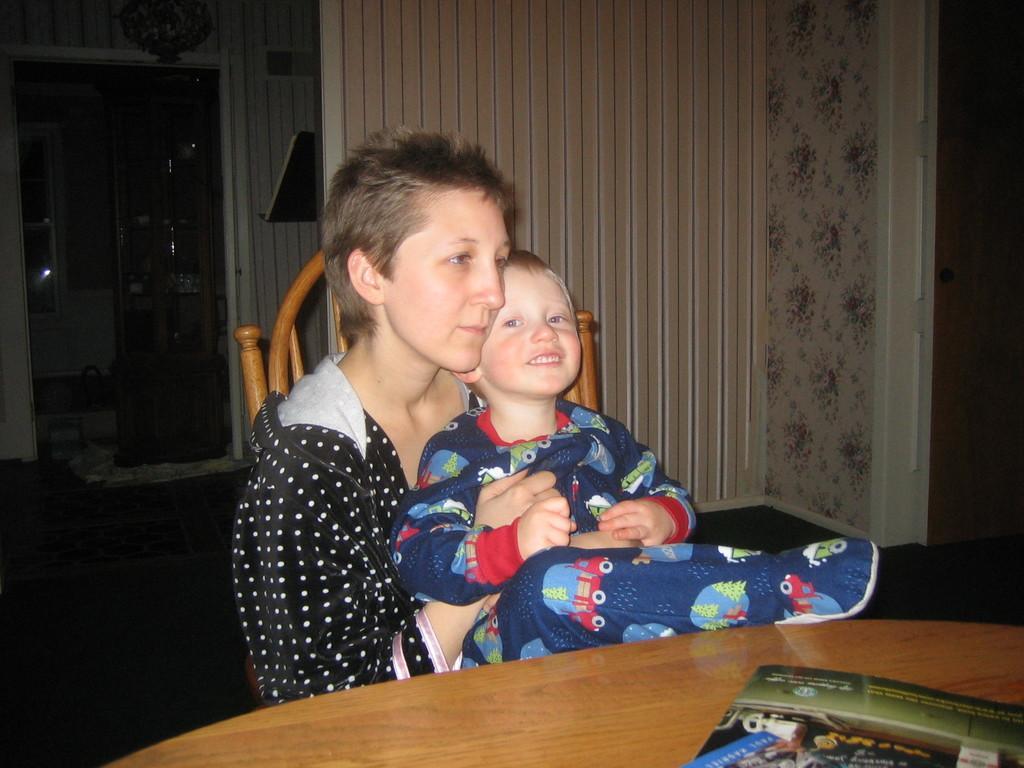Can you describe this image briefly? In this picture there is a woman sitting in chair and holding a kid in her hands and there is a table in front of them which has a book on it and there are some other objects in the background. 